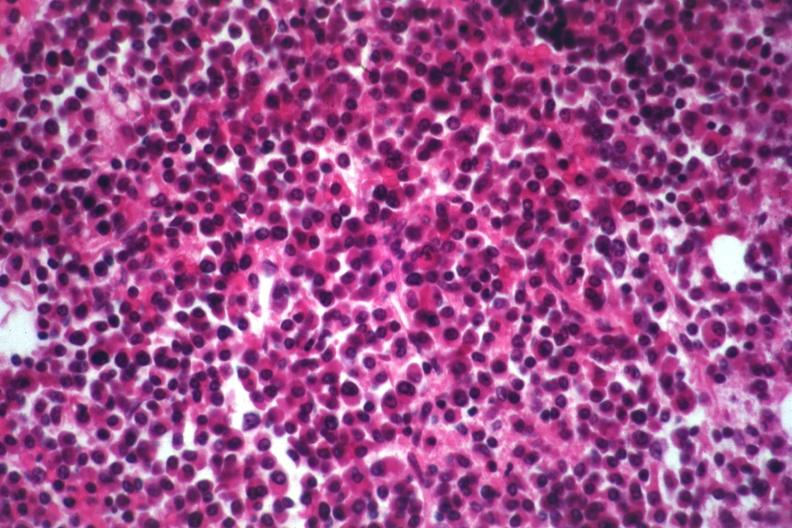what is present?
Answer the question using a single word or phrase. Hematologic 